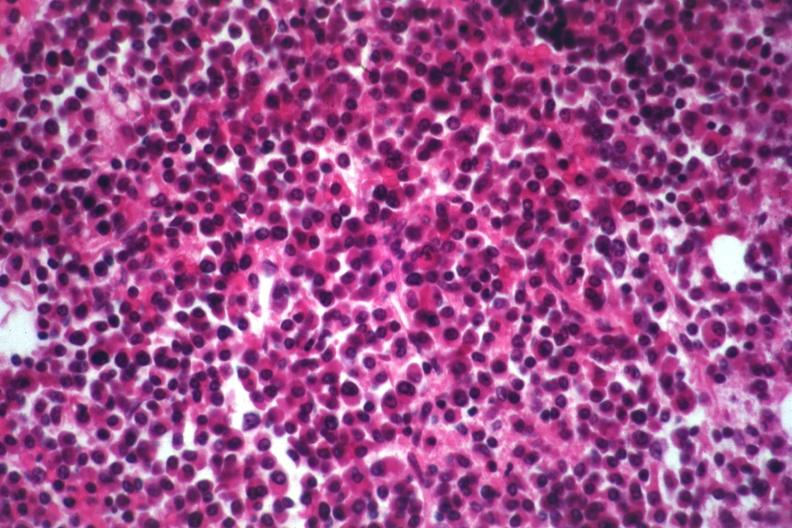what is present?
Answer the question using a single word or phrase. Hematologic 